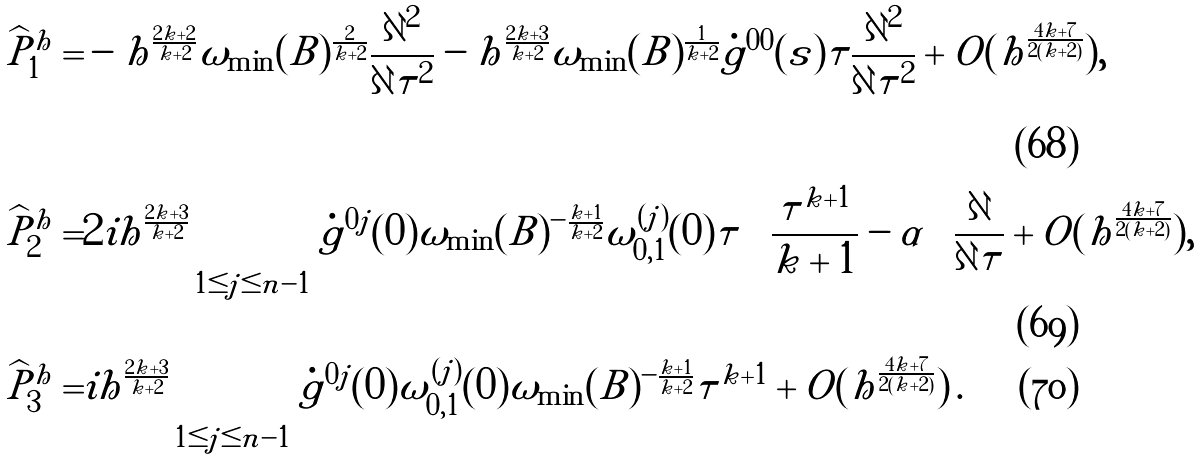Convert formula to latex. <formula><loc_0><loc_0><loc_500><loc_500>\widehat { P } _ { 1 } ^ { h } = & - h ^ { \frac { 2 k + 2 } { k + 2 } } \omega _ { \min } ( B ) ^ { \frac { 2 } { k + 2 } } \frac { { \partial } ^ { 2 } } { \partial \tau ^ { 2 } } - h ^ { \frac { 2 k + 3 } { k + 2 } } \omega _ { \min } ( B ) ^ { \frac { 1 } { k + 2 } } \dot { g } ^ { 0 0 } ( s ) \tau \frac { { \partial } ^ { 2 } } { \partial \tau ^ { 2 } } + O ( h ^ { \frac { 4 k + 7 } { 2 ( k + 2 ) } } ) , \\ \widehat { P } _ { 2 } ^ { h } = & 2 i h ^ { \frac { 2 k + 3 } { k + 2 } } \sum _ { 1 \leq j \leq n - 1 } \dot { g } ^ { 0 j } ( 0 ) \omega _ { \min } ( B ) ^ { - \frac { k + 1 } { k + 2 } } \omega _ { 0 , 1 } ^ { ( j ) } ( 0 ) \tau \left ( \frac { \tau ^ { k + 1 } } { k + 1 } - \alpha \right ) \frac { \partial } { \partial \tau } + O ( h ^ { \frac { 4 k + 7 } { 2 ( k + 2 ) } } ) , \\ \widehat { P } _ { 3 } ^ { h } = & i h ^ { \frac { 2 k + 3 } { k + 2 } } \sum _ { 1 \leq j \leq n - 1 } \dot { g } ^ { 0 j } ( 0 ) \omega _ { 0 , 1 } ^ { ( j ) } ( 0 ) \omega _ { \min } ( B ) ^ { - \frac { k + 1 } { k + 2 } } \tau ^ { k + 1 } + O ( h ^ { \frac { 4 k + 7 } { 2 ( k + 2 ) } } ) \, .</formula> 